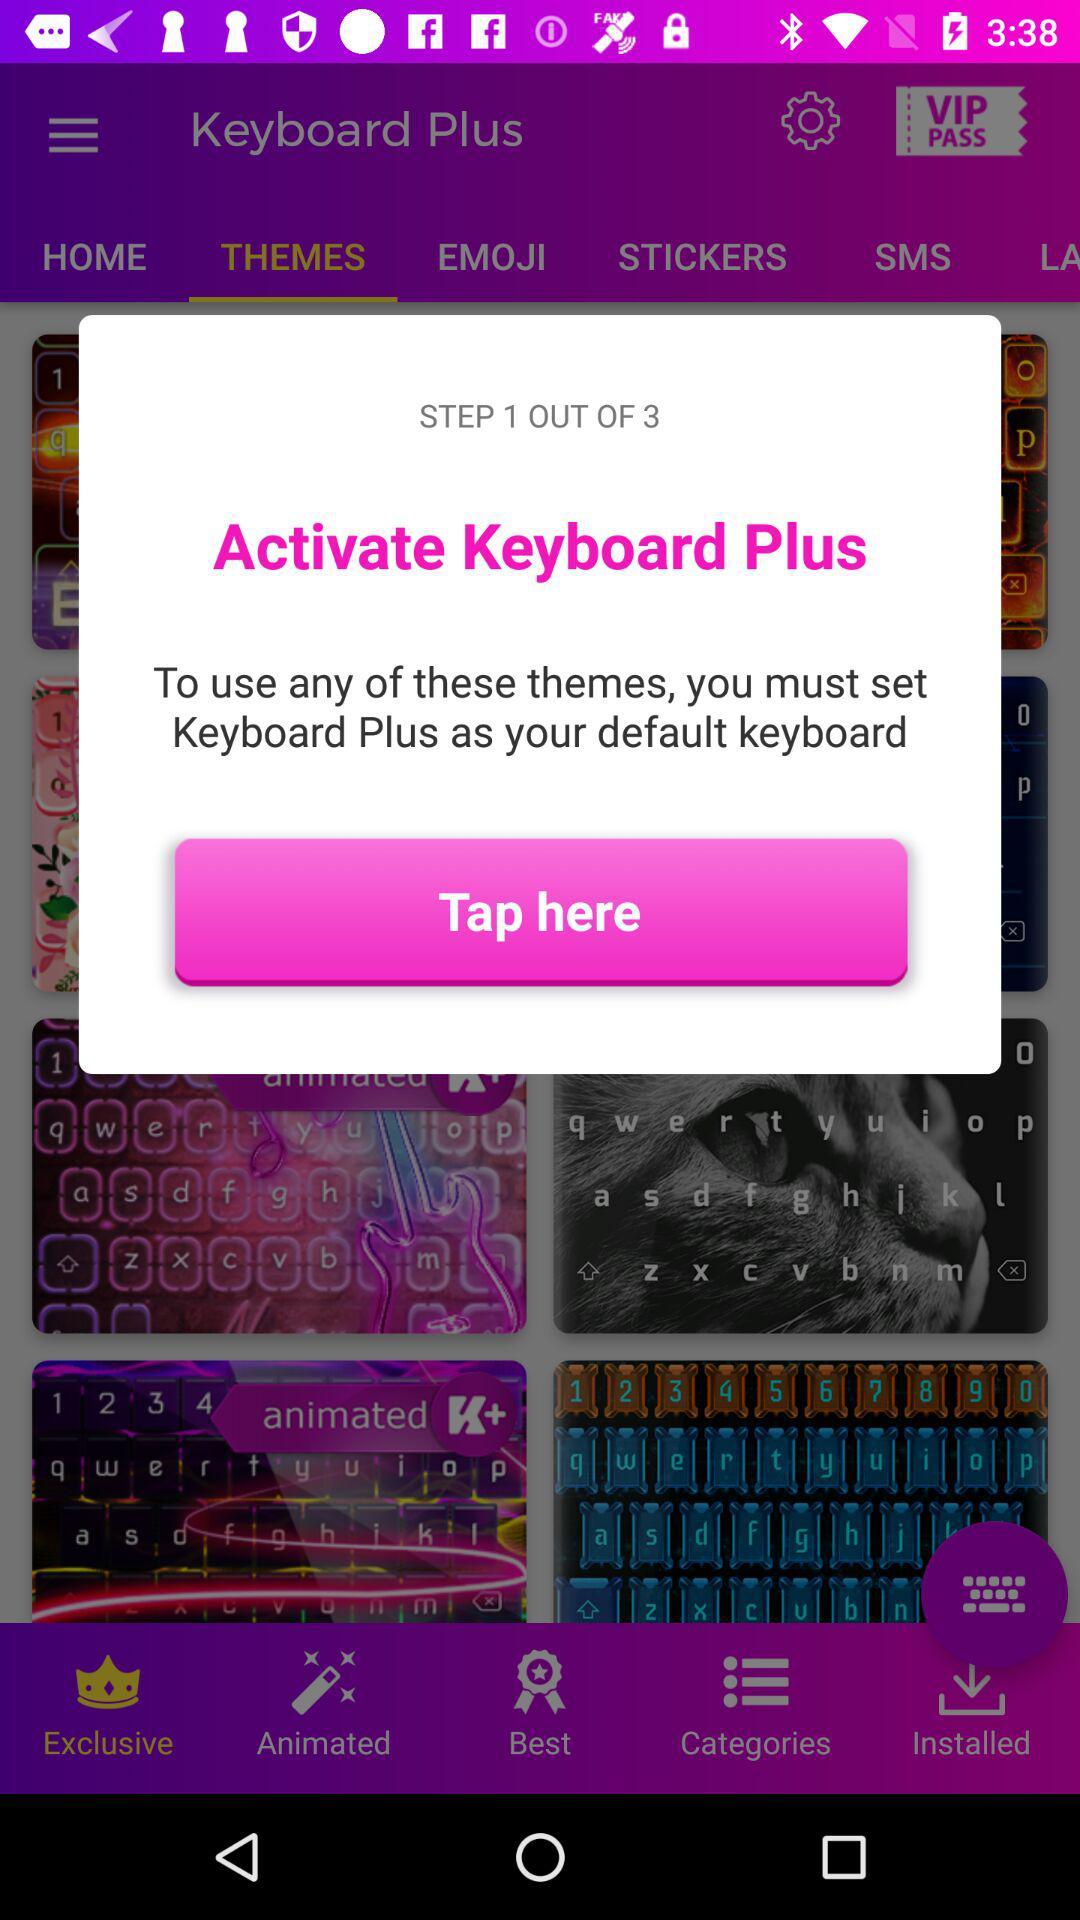At which step am I? You are the step 1. 